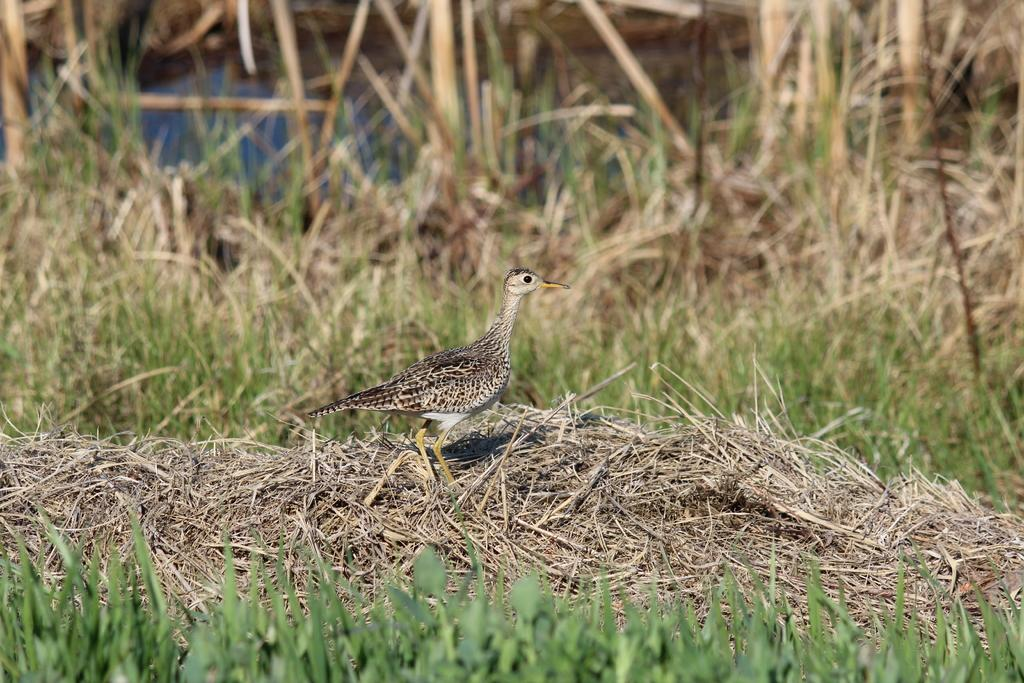What type of animal can be seen in the image? There is a bird in the image. What is the bird standing on? The bird is standing on dry grass. What type of vegetation is visible in the image? There is grass visible in the image. How would you describe the background of the image? The background of the image is blurred. What type of noise is the oven making in the image? There is no oven present in the image, so it is not possible to determine what noise it might be making. 